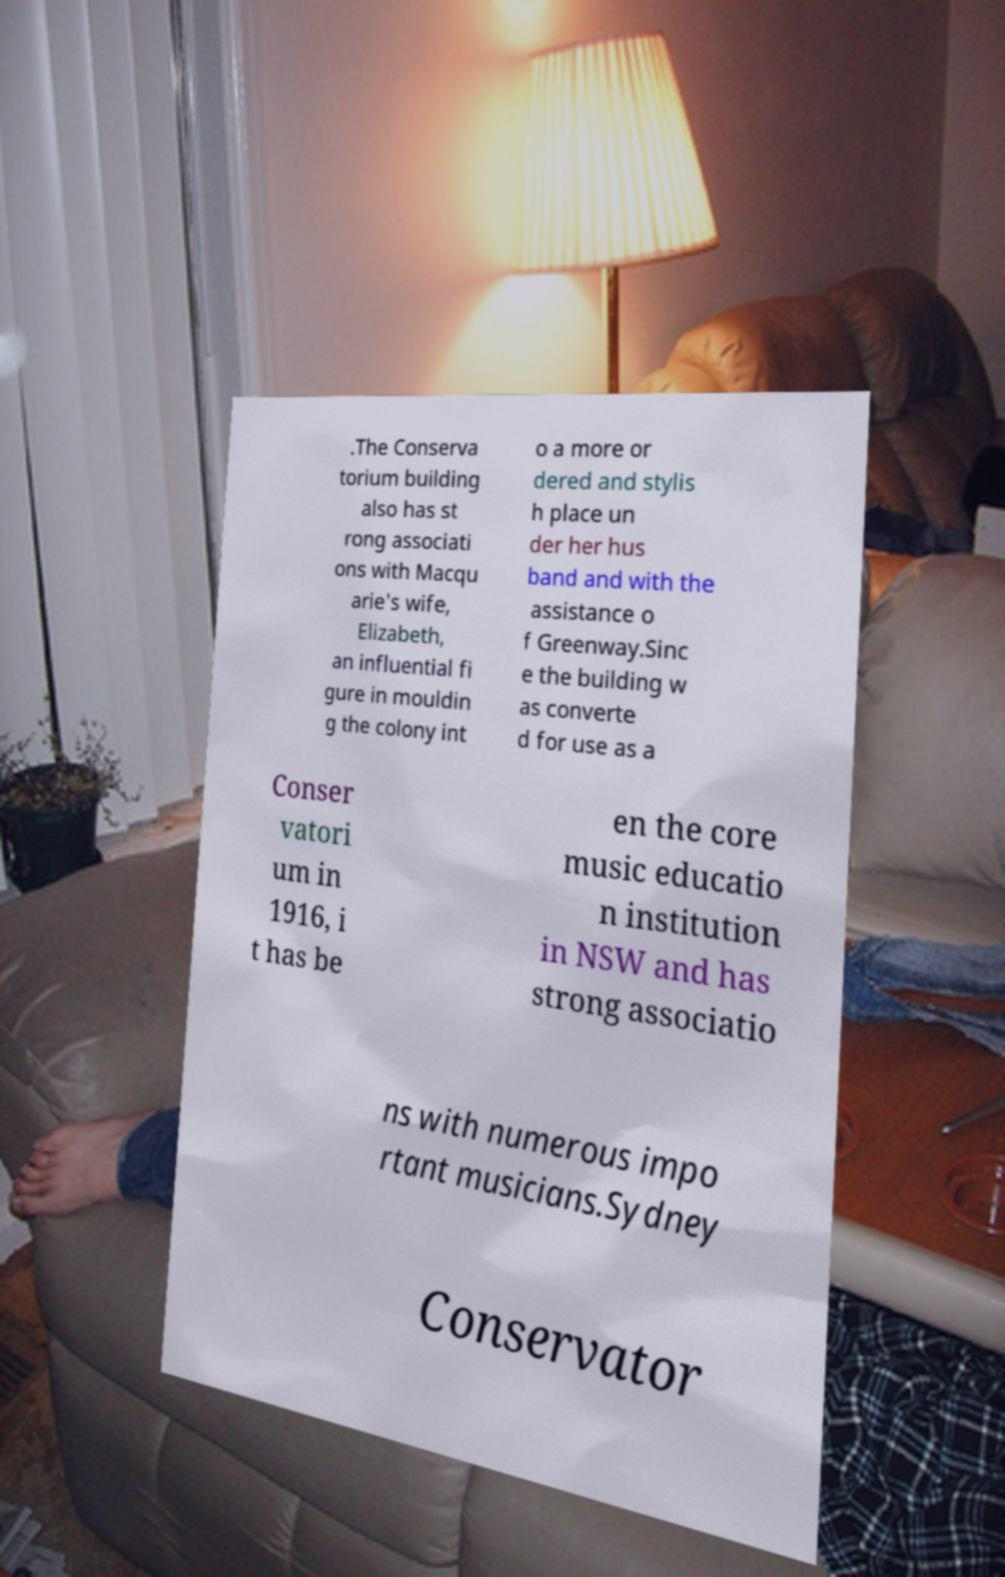I need the written content from this picture converted into text. Can you do that? .The Conserva torium building also has st rong associati ons with Macqu arie's wife, Elizabeth, an influential fi gure in mouldin g the colony int o a more or dered and stylis h place un der her hus band and with the assistance o f Greenway.Sinc e the building w as converte d for use as a Conser vatori um in 1916, i t has be en the core music educatio n institution in NSW and has strong associatio ns with numerous impo rtant musicians.Sydney Conservator 